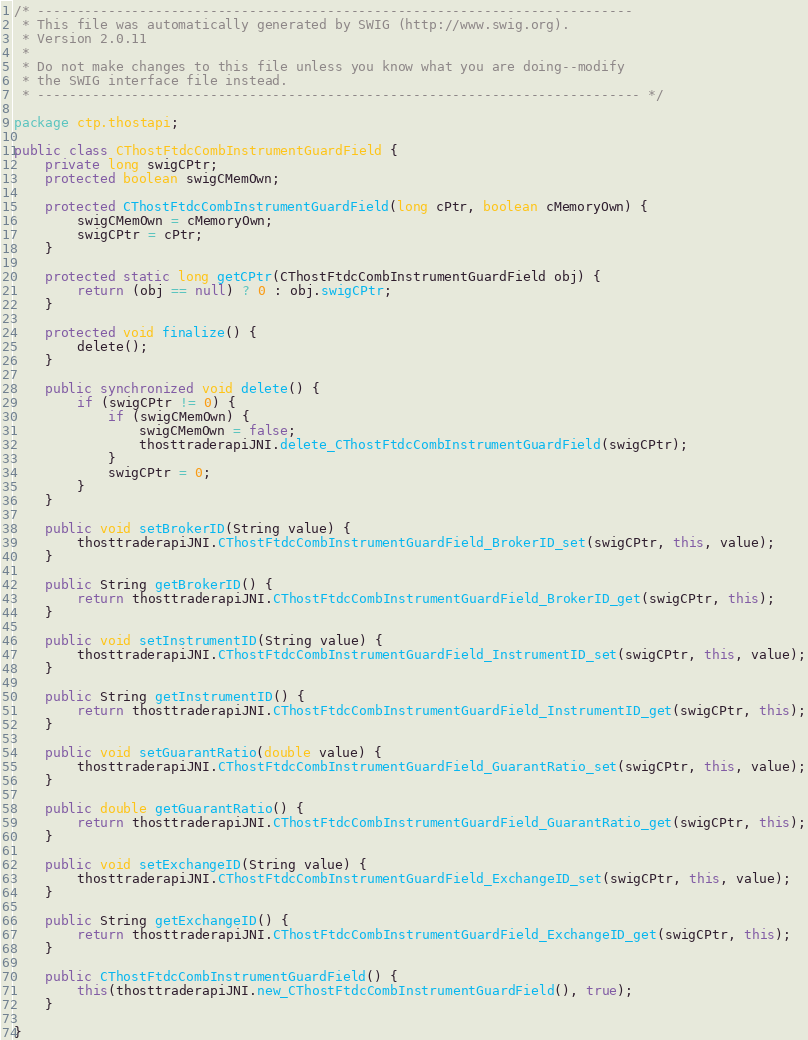<code> <loc_0><loc_0><loc_500><loc_500><_Java_>/* ----------------------------------------------------------------------------
 * This file was automatically generated by SWIG (http://www.swig.org).
 * Version 2.0.11
 *
 * Do not make changes to this file unless you know what you are doing--modify
 * the SWIG interface file instead.
 * ----------------------------------------------------------------------------- */

package ctp.thostapi;

public class CThostFtdcCombInstrumentGuardField {
	private long swigCPtr;
	protected boolean swigCMemOwn;

	protected CThostFtdcCombInstrumentGuardField(long cPtr, boolean cMemoryOwn) {
		swigCMemOwn = cMemoryOwn;
		swigCPtr = cPtr;
	}

	protected static long getCPtr(CThostFtdcCombInstrumentGuardField obj) {
		return (obj == null) ? 0 : obj.swigCPtr;
	}

	protected void finalize() {
		delete();
	}

	public synchronized void delete() {
		if (swigCPtr != 0) {
			if (swigCMemOwn) {
				swigCMemOwn = false;
				thosttraderapiJNI.delete_CThostFtdcCombInstrumentGuardField(swigCPtr);
			}
			swigCPtr = 0;
		}
	}

	public void setBrokerID(String value) {
		thosttraderapiJNI.CThostFtdcCombInstrumentGuardField_BrokerID_set(swigCPtr, this, value);
	}

	public String getBrokerID() {
		return thosttraderapiJNI.CThostFtdcCombInstrumentGuardField_BrokerID_get(swigCPtr, this);
	}

	public void setInstrumentID(String value) {
		thosttraderapiJNI.CThostFtdcCombInstrumentGuardField_InstrumentID_set(swigCPtr, this, value);
	}

	public String getInstrumentID() {
		return thosttraderapiJNI.CThostFtdcCombInstrumentGuardField_InstrumentID_get(swigCPtr, this);
	}

	public void setGuarantRatio(double value) {
		thosttraderapiJNI.CThostFtdcCombInstrumentGuardField_GuarantRatio_set(swigCPtr, this, value);
	}

	public double getGuarantRatio() {
		return thosttraderapiJNI.CThostFtdcCombInstrumentGuardField_GuarantRatio_get(swigCPtr, this);
	}

	public void setExchangeID(String value) {
		thosttraderapiJNI.CThostFtdcCombInstrumentGuardField_ExchangeID_set(swigCPtr, this, value);
	}

	public String getExchangeID() {
		return thosttraderapiJNI.CThostFtdcCombInstrumentGuardField_ExchangeID_get(swigCPtr, this);
	}

	public CThostFtdcCombInstrumentGuardField() {
		this(thosttraderapiJNI.new_CThostFtdcCombInstrumentGuardField(), true);
	}

}
</code> 